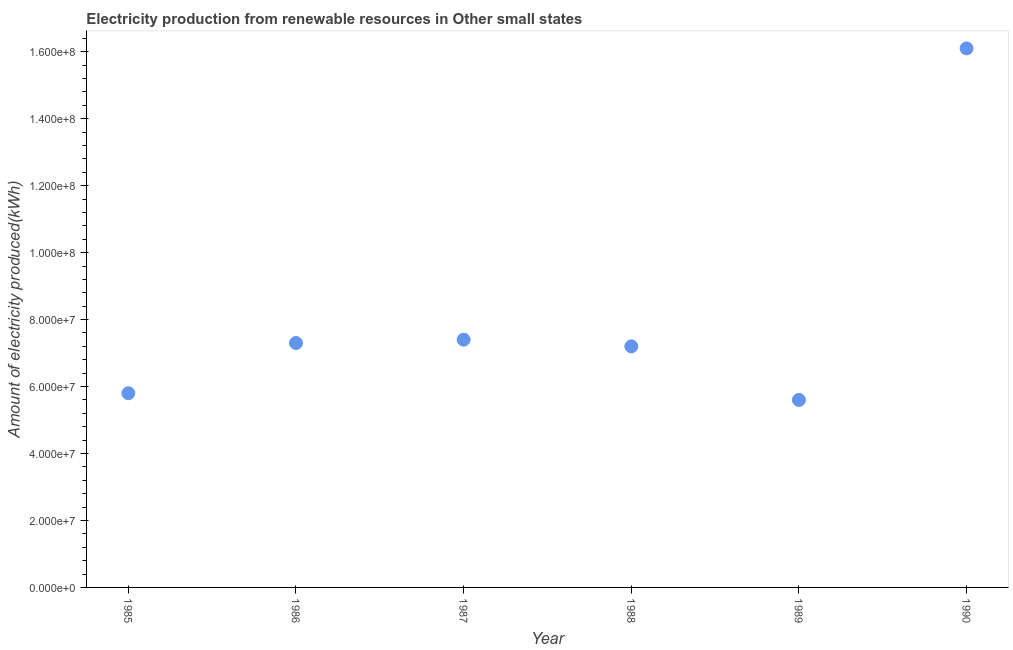What is the amount of electricity produced in 1990?
Give a very brief answer. 1.61e+08. Across all years, what is the maximum amount of electricity produced?
Offer a terse response. 1.61e+08. Across all years, what is the minimum amount of electricity produced?
Provide a short and direct response. 5.60e+07. In which year was the amount of electricity produced maximum?
Make the answer very short. 1990. In which year was the amount of electricity produced minimum?
Your answer should be very brief. 1989. What is the sum of the amount of electricity produced?
Give a very brief answer. 4.94e+08. What is the difference between the amount of electricity produced in 1986 and 1988?
Make the answer very short. 1.00e+06. What is the average amount of electricity produced per year?
Make the answer very short. 8.23e+07. What is the median amount of electricity produced?
Provide a succinct answer. 7.25e+07. Do a majority of the years between 1988 and 1989 (inclusive) have amount of electricity produced greater than 52000000 kWh?
Provide a succinct answer. Yes. What is the ratio of the amount of electricity produced in 1987 to that in 1989?
Your answer should be compact. 1.32. Is the amount of electricity produced in 1985 less than that in 1988?
Ensure brevity in your answer.  Yes. Is the difference between the amount of electricity produced in 1988 and 1990 greater than the difference between any two years?
Your answer should be very brief. No. What is the difference between the highest and the second highest amount of electricity produced?
Your answer should be compact. 8.70e+07. Is the sum of the amount of electricity produced in 1987 and 1989 greater than the maximum amount of electricity produced across all years?
Give a very brief answer. No. What is the difference between the highest and the lowest amount of electricity produced?
Keep it short and to the point. 1.05e+08. How many dotlines are there?
Ensure brevity in your answer.  1. How many years are there in the graph?
Your answer should be compact. 6. Are the values on the major ticks of Y-axis written in scientific E-notation?
Make the answer very short. Yes. Does the graph contain grids?
Ensure brevity in your answer.  No. What is the title of the graph?
Provide a succinct answer. Electricity production from renewable resources in Other small states. What is the label or title of the Y-axis?
Your response must be concise. Amount of electricity produced(kWh). What is the Amount of electricity produced(kWh) in 1985?
Your answer should be very brief. 5.80e+07. What is the Amount of electricity produced(kWh) in 1986?
Make the answer very short. 7.30e+07. What is the Amount of electricity produced(kWh) in 1987?
Offer a very short reply. 7.40e+07. What is the Amount of electricity produced(kWh) in 1988?
Offer a very short reply. 7.20e+07. What is the Amount of electricity produced(kWh) in 1989?
Give a very brief answer. 5.60e+07. What is the Amount of electricity produced(kWh) in 1990?
Offer a terse response. 1.61e+08. What is the difference between the Amount of electricity produced(kWh) in 1985 and 1986?
Your response must be concise. -1.50e+07. What is the difference between the Amount of electricity produced(kWh) in 1985 and 1987?
Your answer should be compact. -1.60e+07. What is the difference between the Amount of electricity produced(kWh) in 1985 and 1988?
Your answer should be compact. -1.40e+07. What is the difference between the Amount of electricity produced(kWh) in 1985 and 1989?
Your response must be concise. 2.00e+06. What is the difference between the Amount of electricity produced(kWh) in 1985 and 1990?
Keep it short and to the point. -1.03e+08. What is the difference between the Amount of electricity produced(kWh) in 1986 and 1988?
Provide a succinct answer. 1.00e+06. What is the difference between the Amount of electricity produced(kWh) in 1986 and 1989?
Your answer should be compact. 1.70e+07. What is the difference between the Amount of electricity produced(kWh) in 1986 and 1990?
Your answer should be compact. -8.80e+07. What is the difference between the Amount of electricity produced(kWh) in 1987 and 1989?
Offer a terse response. 1.80e+07. What is the difference between the Amount of electricity produced(kWh) in 1987 and 1990?
Offer a terse response. -8.70e+07. What is the difference between the Amount of electricity produced(kWh) in 1988 and 1989?
Offer a very short reply. 1.60e+07. What is the difference between the Amount of electricity produced(kWh) in 1988 and 1990?
Your answer should be very brief. -8.90e+07. What is the difference between the Amount of electricity produced(kWh) in 1989 and 1990?
Keep it short and to the point. -1.05e+08. What is the ratio of the Amount of electricity produced(kWh) in 1985 to that in 1986?
Ensure brevity in your answer.  0.8. What is the ratio of the Amount of electricity produced(kWh) in 1985 to that in 1987?
Provide a succinct answer. 0.78. What is the ratio of the Amount of electricity produced(kWh) in 1985 to that in 1988?
Offer a terse response. 0.81. What is the ratio of the Amount of electricity produced(kWh) in 1985 to that in 1989?
Provide a short and direct response. 1.04. What is the ratio of the Amount of electricity produced(kWh) in 1985 to that in 1990?
Offer a terse response. 0.36. What is the ratio of the Amount of electricity produced(kWh) in 1986 to that in 1989?
Give a very brief answer. 1.3. What is the ratio of the Amount of electricity produced(kWh) in 1986 to that in 1990?
Your answer should be compact. 0.45. What is the ratio of the Amount of electricity produced(kWh) in 1987 to that in 1988?
Your response must be concise. 1.03. What is the ratio of the Amount of electricity produced(kWh) in 1987 to that in 1989?
Offer a terse response. 1.32. What is the ratio of the Amount of electricity produced(kWh) in 1987 to that in 1990?
Your response must be concise. 0.46. What is the ratio of the Amount of electricity produced(kWh) in 1988 to that in 1989?
Your answer should be very brief. 1.29. What is the ratio of the Amount of electricity produced(kWh) in 1988 to that in 1990?
Make the answer very short. 0.45. What is the ratio of the Amount of electricity produced(kWh) in 1989 to that in 1990?
Provide a short and direct response. 0.35. 